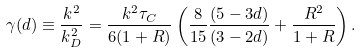Convert formula to latex. <formula><loc_0><loc_0><loc_500><loc_500>\gamma ( d ) \equiv \frac { k ^ { 2 } } { k _ { D } ^ { 2 } } = \frac { k ^ { 2 } \tau _ { C } } { 6 ( 1 + R ) } \left ( \frac { 8 } { 1 5 } \frac { ( 5 - 3 d ) } { ( 3 - 2 d ) } + \frac { R ^ { 2 } } { 1 + R } \right ) .</formula> 